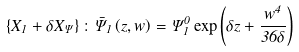Convert formula to latex. <formula><loc_0><loc_0><loc_500><loc_500>\left \{ X _ { 1 } + \delta X _ { \Psi } \right \} \colon \bar { \Psi } _ { 1 } \left ( z , w \right ) = \Psi _ { 1 } ^ { 0 } \exp \left ( \delta z + \frac { w ^ { 4 } } { 3 6 \delta } \right )</formula> 